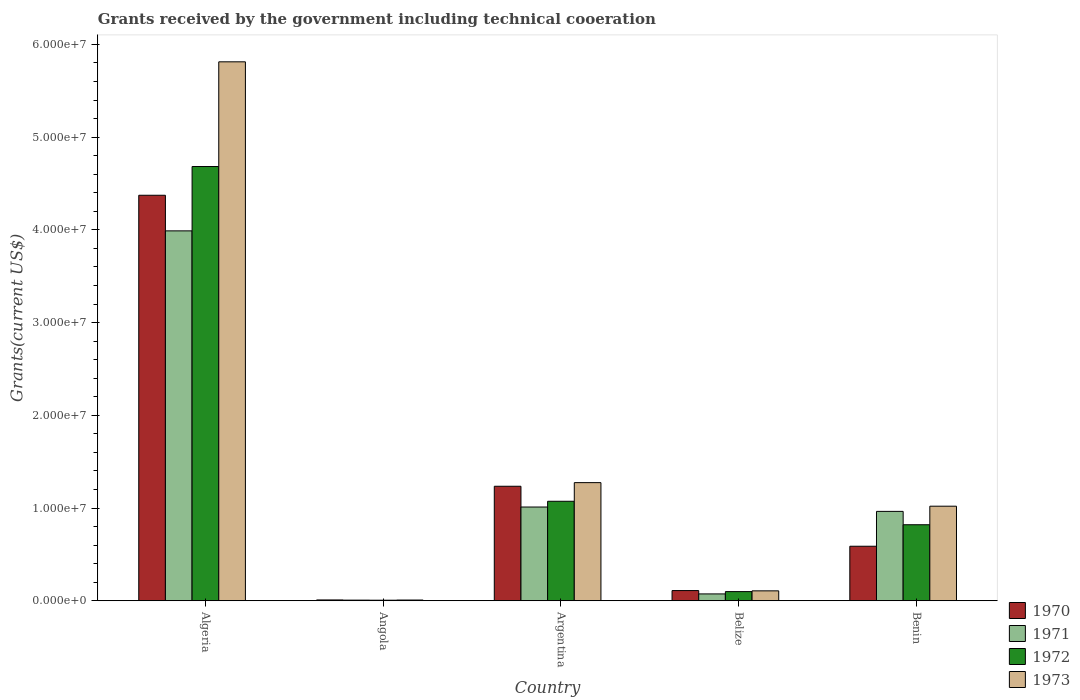Are the number of bars per tick equal to the number of legend labels?
Offer a terse response. Yes. Are the number of bars on each tick of the X-axis equal?
Ensure brevity in your answer.  Yes. How many bars are there on the 4th tick from the right?
Offer a terse response. 4. What is the label of the 4th group of bars from the left?
Ensure brevity in your answer.  Belize. In how many cases, is the number of bars for a given country not equal to the number of legend labels?
Ensure brevity in your answer.  0. What is the total grants received by the government in 1972 in Benin?
Keep it short and to the point. 8.20e+06. Across all countries, what is the maximum total grants received by the government in 1971?
Keep it short and to the point. 3.99e+07. Across all countries, what is the minimum total grants received by the government in 1971?
Your answer should be compact. 7.00e+04. In which country was the total grants received by the government in 1972 maximum?
Offer a terse response. Algeria. In which country was the total grants received by the government in 1973 minimum?
Keep it short and to the point. Angola. What is the total total grants received by the government in 1973 in the graph?
Your response must be concise. 8.22e+07. What is the difference between the total grants received by the government in 1972 in Algeria and that in Angola?
Give a very brief answer. 4.68e+07. What is the difference between the total grants received by the government in 1971 in Belize and the total grants received by the government in 1970 in Angola?
Your answer should be very brief. 6.50e+05. What is the average total grants received by the government in 1970 per country?
Keep it short and to the point. 1.26e+07. What is the difference between the total grants received by the government of/in 1971 and total grants received by the government of/in 1970 in Benin?
Offer a terse response. 3.76e+06. In how many countries, is the total grants received by the government in 1972 greater than 48000000 US$?
Keep it short and to the point. 0. What is the ratio of the total grants received by the government in 1973 in Argentina to that in Belize?
Offer a very short reply. 11.91. What is the difference between the highest and the second highest total grants received by the government in 1971?
Your response must be concise. 2.98e+07. What is the difference between the highest and the lowest total grants received by the government in 1973?
Make the answer very short. 5.80e+07. Is it the case that in every country, the sum of the total grants received by the government in 1973 and total grants received by the government in 1970 is greater than the sum of total grants received by the government in 1972 and total grants received by the government in 1971?
Your answer should be very brief. No. How many countries are there in the graph?
Ensure brevity in your answer.  5. What is the difference between two consecutive major ticks on the Y-axis?
Provide a succinct answer. 1.00e+07. Does the graph contain grids?
Provide a short and direct response. No. How are the legend labels stacked?
Offer a terse response. Vertical. What is the title of the graph?
Give a very brief answer. Grants received by the government including technical cooeration. Does "1994" appear as one of the legend labels in the graph?
Your answer should be very brief. No. What is the label or title of the X-axis?
Give a very brief answer. Country. What is the label or title of the Y-axis?
Your answer should be compact. Grants(current US$). What is the Grants(current US$) in 1970 in Algeria?
Provide a short and direct response. 4.37e+07. What is the Grants(current US$) of 1971 in Algeria?
Provide a succinct answer. 3.99e+07. What is the Grants(current US$) of 1972 in Algeria?
Give a very brief answer. 4.68e+07. What is the Grants(current US$) in 1973 in Algeria?
Offer a terse response. 5.81e+07. What is the Grants(current US$) in 1970 in Angola?
Your response must be concise. 9.00e+04. What is the Grants(current US$) of 1971 in Angola?
Offer a terse response. 7.00e+04. What is the Grants(current US$) in 1973 in Angola?
Your response must be concise. 8.00e+04. What is the Grants(current US$) in 1970 in Argentina?
Your answer should be compact. 1.24e+07. What is the Grants(current US$) of 1971 in Argentina?
Your response must be concise. 1.01e+07. What is the Grants(current US$) in 1972 in Argentina?
Make the answer very short. 1.07e+07. What is the Grants(current US$) of 1973 in Argentina?
Give a very brief answer. 1.27e+07. What is the Grants(current US$) of 1970 in Belize?
Your answer should be very brief. 1.10e+06. What is the Grants(current US$) in 1971 in Belize?
Keep it short and to the point. 7.40e+05. What is the Grants(current US$) in 1972 in Belize?
Offer a terse response. 9.90e+05. What is the Grants(current US$) in 1973 in Belize?
Your answer should be very brief. 1.07e+06. What is the Grants(current US$) in 1970 in Benin?
Your response must be concise. 5.88e+06. What is the Grants(current US$) of 1971 in Benin?
Your answer should be compact. 9.64e+06. What is the Grants(current US$) in 1972 in Benin?
Make the answer very short. 8.20e+06. What is the Grants(current US$) in 1973 in Benin?
Provide a short and direct response. 1.02e+07. Across all countries, what is the maximum Grants(current US$) of 1970?
Provide a short and direct response. 4.37e+07. Across all countries, what is the maximum Grants(current US$) in 1971?
Offer a very short reply. 3.99e+07. Across all countries, what is the maximum Grants(current US$) in 1972?
Offer a terse response. 4.68e+07. Across all countries, what is the maximum Grants(current US$) in 1973?
Offer a terse response. 5.81e+07. Across all countries, what is the minimum Grants(current US$) of 1971?
Provide a short and direct response. 7.00e+04. What is the total Grants(current US$) of 1970 in the graph?
Your answer should be compact. 6.32e+07. What is the total Grants(current US$) in 1971 in the graph?
Provide a succinct answer. 6.04e+07. What is the total Grants(current US$) in 1972 in the graph?
Ensure brevity in your answer.  6.68e+07. What is the total Grants(current US$) of 1973 in the graph?
Keep it short and to the point. 8.22e+07. What is the difference between the Grants(current US$) in 1970 in Algeria and that in Angola?
Keep it short and to the point. 4.36e+07. What is the difference between the Grants(current US$) of 1971 in Algeria and that in Angola?
Offer a very short reply. 3.98e+07. What is the difference between the Grants(current US$) of 1972 in Algeria and that in Angola?
Ensure brevity in your answer.  4.68e+07. What is the difference between the Grants(current US$) in 1973 in Algeria and that in Angola?
Offer a very short reply. 5.80e+07. What is the difference between the Grants(current US$) in 1970 in Algeria and that in Argentina?
Your answer should be compact. 3.14e+07. What is the difference between the Grants(current US$) of 1971 in Algeria and that in Argentina?
Provide a succinct answer. 2.98e+07. What is the difference between the Grants(current US$) of 1972 in Algeria and that in Argentina?
Keep it short and to the point. 3.61e+07. What is the difference between the Grants(current US$) of 1973 in Algeria and that in Argentina?
Offer a very short reply. 4.54e+07. What is the difference between the Grants(current US$) of 1970 in Algeria and that in Belize?
Keep it short and to the point. 4.26e+07. What is the difference between the Grants(current US$) in 1971 in Algeria and that in Belize?
Your answer should be compact. 3.92e+07. What is the difference between the Grants(current US$) in 1972 in Algeria and that in Belize?
Your response must be concise. 4.58e+07. What is the difference between the Grants(current US$) in 1973 in Algeria and that in Belize?
Provide a succinct answer. 5.70e+07. What is the difference between the Grants(current US$) in 1970 in Algeria and that in Benin?
Give a very brief answer. 3.78e+07. What is the difference between the Grants(current US$) of 1971 in Algeria and that in Benin?
Make the answer very short. 3.02e+07. What is the difference between the Grants(current US$) in 1972 in Algeria and that in Benin?
Your response must be concise. 3.86e+07. What is the difference between the Grants(current US$) in 1973 in Algeria and that in Benin?
Ensure brevity in your answer.  4.79e+07. What is the difference between the Grants(current US$) in 1970 in Angola and that in Argentina?
Give a very brief answer. -1.23e+07. What is the difference between the Grants(current US$) in 1971 in Angola and that in Argentina?
Keep it short and to the point. -1.00e+07. What is the difference between the Grants(current US$) of 1972 in Angola and that in Argentina?
Provide a short and direct response. -1.07e+07. What is the difference between the Grants(current US$) of 1973 in Angola and that in Argentina?
Give a very brief answer. -1.27e+07. What is the difference between the Grants(current US$) in 1970 in Angola and that in Belize?
Provide a succinct answer. -1.01e+06. What is the difference between the Grants(current US$) of 1971 in Angola and that in Belize?
Ensure brevity in your answer.  -6.70e+05. What is the difference between the Grants(current US$) in 1972 in Angola and that in Belize?
Your answer should be compact. -9.30e+05. What is the difference between the Grants(current US$) in 1973 in Angola and that in Belize?
Your answer should be very brief. -9.90e+05. What is the difference between the Grants(current US$) of 1970 in Angola and that in Benin?
Your response must be concise. -5.79e+06. What is the difference between the Grants(current US$) in 1971 in Angola and that in Benin?
Provide a short and direct response. -9.57e+06. What is the difference between the Grants(current US$) in 1972 in Angola and that in Benin?
Provide a succinct answer. -8.14e+06. What is the difference between the Grants(current US$) of 1973 in Angola and that in Benin?
Your answer should be very brief. -1.01e+07. What is the difference between the Grants(current US$) in 1970 in Argentina and that in Belize?
Provide a succinct answer. 1.12e+07. What is the difference between the Grants(current US$) in 1971 in Argentina and that in Belize?
Ensure brevity in your answer.  9.37e+06. What is the difference between the Grants(current US$) of 1972 in Argentina and that in Belize?
Make the answer very short. 9.74e+06. What is the difference between the Grants(current US$) in 1973 in Argentina and that in Belize?
Your answer should be compact. 1.17e+07. What is the difference between the Grants(current US$) of 1970 in Argentina and that in Benin?
Provide a short and direct response. 6.47e+06. What is the difference between the Grants(current US$) in 1971 in Argentina and that in Benin?
Your answer should be compact. 4.70e+05. What is the difference between the Grants(current US$) in 1972 in Argentina and that in Benin?
Ensure brevity in your answer.  2.53e+06. What is the difference between the Grants(current US$) of 1973 in Argentina and that in Benin?
Your answer should be compact. 2.54e+06. What is the difference between the Grants(current US$) of 1970 in Belize and that in Benin?
Provide a succinct answer. -4.78e+06. What is the difference between the Grants(current US$) of 1971 in Belize and that in Benin?
Keep it short and to the point. -8.90e+06. What is the difference between the Grants(current US$) of 1972 in Belize and that in Benin?
Provide a succinct answer. -7.21e+06. What is the difference between the Grants(current US$) of 1973 in Belize and that in Benin?
Your response must be concise. -9.13e+06. What is the difference between the Grants(current US$) of 1970 in Algeria and the Grants(current US$) of 1971 in Angola?
Give a very brief answer. 4.37e+07. What is the difference between the Grants(current US$) of 1970 in Algeria and the Grants(current US$) of 1972 in Angola?
Keep it short and to the point. 4.37e+07. What is the difference between the Grants(current US$) of 1970 in Algeria and the Grants(current US$) of 1973 in Angola?
Offer a terse response. 4.36e+07. What is the difference between the Grants(current US$) in 1971 in Algeria and the Grants(current US$) in 1972 in Angola?
Your answer should be compact. 3.98e+07. What is the difference between the Grants(current US$) of 1971 in Algeria and the Grants(current US$) of 1973 in Angola?
Offer a very short reply. 3.98e+07. What is the difference between the Grants(current US$) in 1972 in Algeria and the Grants(current US$) in 1973 in Angola?
Your answer should be very brief. 4.68e+07. What is the difference between the Grants(current US$) of 1970 in Algeria and the Grants(current US$) of 1971 in Argentina?
Provide a succinct answer. 3.36e+07. What is the difference between the Grants(current US$) in 1970 in Algeria and the Grants(current US$) in 1972 in Argentina?
Make the answer very short. 3.30e+07. What is the difference between the Grants(current US$) in 1970 in Algeria and the Grants(current US$) in 1973 in Argentina?
Your answer should be compact. 3.10e+07. What is the difference between the Grants(current US$) of 1971 in Algeria and the Grants(current US$) of 1972 in Argentina?
Give a very brief answer. 2.92e+07. What is the difference between the Grants(current US$) in 1971 in Algeria and the Grants(current US$) in 1973 in Argentina?
Your answer should be very brief. 2.72e+07. What is the difference between the Grants(current US$) in 1972 in Algeria and the Grants(current US$) in 1973 in Argentina?
Your response must be concise. 3.41e+07. What is the difference between the Grants(current US$) in 1970 in Algeria and the Grants(current US$) in 1971 in Belize?
Your answer should be compact. 4.30e+07. What is the difference between the Grants(current US$) in 1970 in Algeria and the Grants(current US$) in 1972 in Belize?
Offer a very short reply. 4.27e+07. What is the difference between the Grants(current US$) of 1970 in Algeria and the Grants(current US$) of 1973 in Belize?
Offer a very short reply. 4.27e+07. What is the difference between the Grants(current US$) in 1971 in Algeria and the Grants(current US$) in 1972 in Belize?
Ensure brevity in your answer.  3.89e+07. What is the difference between the Grants(current US$) in 1971 in Algeria and the Grants(current US$) in 1973 in Belize?
Make the answer very short. 3.88e+07. What is the difference between the Grants(current US$) in 1972 in Algeria and the Grants(current US$) in 1973 in Belize?
Your answer should be very brief. 4.58e+07. What is the difference between the Grants(current US$) of 1970 in Algeria and the Grants(current US$) of 1971 in Benin?
Make the answer very short. 3.41e+07. What is the difference between the Grants(current US$) in 1970 in Algeria and the Grants(current US$) in 1972 in Benin?
Your answer should be compact. 3.55e+07. What is the difference between the Grants(current US$) in 1970 in Algeria and the Grants(current US$) in 1973 in Benin?
Make the answer very short. 3.35e+07. What is the difference between the Grants(current US$) in 1971 in Algeria and the Grants(current US$) in 1972 in Benin?
Give a very brief answer. 3.17e+07. What is the difference between the Grants(current US$) of 1971 in Algeria and the Grants(current US$) of 1973 in Benin?
Provide a short and direct response. 2.97e+07. What is the difference between the Grants(current US$) of 1972 in Algeria and the Grants(current US$) of 1973 in Benin?
Your response must be concise. 3.66e+07. What is the difference between the Grants(current US$) of 1970 in Angola and the Grants(current US$) of 1971 in Argentina?
Keep it short and to the point. -1.00e+07. What is the difference between the Grants(current US$) of 1970 in Angola and the Grants(current US$) of 1972 in Argentina?
Your answer should be very brief. -1.06e+07. What is the difference between the Grants(current US$) in 1970 in Angola and the Grants(current US$) in 1973 in Argentina?
Make the answer very short. -1.26e+07. What is the difference between the Grants(current US$) of 1971 in Angola and the Grants(current US$) of 1972 in Argentina?
Your answer should be very brief. -1.07e+07. What is the difference between the Grants(current US$) in 1971 in Angola and the Grants(current US$) in 1973 in Argentina?
Provide a succinct answer. -1.27e+07. What is the difference between the Grants(current US$) of 1972 in Angola and the Grants(current US$) of 1973 in Argentina?
Provide a short and direct response. -1.27e+07. What is the difference between the Grants(current US$) in 1970 in Angola and the Grants(current US$) in 1971 in Belize?
Your answer should be compact. -6.50e+05. What is the difference between the Grants(current US$) of 1970 in Angola and the Grants(current US$) of 1972 in Belize?
Provide a succinct answer. -9.00e+05. What is the difference between the Grants(current US$) of 1970 in Angola and the Grants(current US$) of 1973 in Belize?
Offer a very short reply. -9.80e+05. What is the difference between the Grants(current US$) in 1971 in Angola and the Grants(current US$) in 1972 in Belize?
Your response must be concise. -9.20e+05. What is the difference between the Grants(current US$) in 1971 in Angola and the Grants(current US$) in 1973 in Belize?
Give a very brief answer. -1.00e+06. What is the difference between the Grants(current US$) of 1972 in Angola and the Grants(current US$) of 1973 in Belize?
Offer a very short reply. -1.01e+06. What is the difference between the Grants(current US$) of 1970 in Angola and the Grants(current US$) of 1971 in Benin?
Your answer should be compact. -9.55e+06. What is the difference between the Grants(current US$) of 1970 in Angola and the Grants(current US$) of 1972 in Benin?
Your response must be concise. -8.11e+06. What is the difference between the Grants(current US$) of 1970 in Angola and the Grants(current US$) of 1973 in Benin?
Provide a succinct answer. -1.01e+07. What is the difference between the Grants(current US$) of 1971 in Angola and the Grants(current US$) of 1972 in Benin?
Ensure brevity in your answer.  -8.13e+06. What is the difference between the Grants(current US$) of 1971 in Angola and the Grants(current US$) of 1973 in Benin?
Your response must be concise. -1.01e+07. What is the difference between the Grants(current US$) of 1972 in Angola and the Grants(current US$) of 1973 in Benin?
Give a very brief answer. -1.01e+07. What is the difference between the Grants(current US$) of 1970 in Argentina and the Grants(current US$) of 1971 in Belize?
Offer a terse response. 1.16e+07. What is the difference between the Grants(current US$) of 1970 in Argentina and the Grants(current US$) of 1972 in Belize?
Offer a very short reply. 1.14e+07. What is the difference between the Grants(current US$) of 1970 in Argentina and the Grants(current US$) of 1973 in Belize?
Your answer should be compact. 1.13e+07. What is the difference between the Grants(current US$) of 1971 in Argentina and the Grants(current US$) of 1972 in Belize?
Offer a very short reply. 9.12e+06. What is the difference between the Grants(current US$) of 1971 in Argentina and the Grants(current US$) of 1973 in Belize?
Keep it short and to the point. 9.04e+06. What is the difference between the Grants(current US$) in 1972 in Argentina and the Grants(current US$) in 1973 in Belize?
Provide a short and direct response. 9.66e+06. What is the difference between the Grants(current US$) in 1970 in Argentina and the Grants(current US$) in 1971 in Benin?
Offer a very short reply. 2.71e+06. What is the difference between the Grants(current US$) of 1970 in Argentina and the Grants(current US$) of 1972 in Benin?
Offer a very short reply. 4.15e+06. What is the difference between the Grants(current US$) of 1970 in Argentina and the Grants(current US$) of 1973 in Benin?
Make the answer very short. 2.15e+06. What is the difference between the Grants(current US$) in 1971 in Argentina and the Grants(current US$) in 1972 in Benin?
Offer a terse response. 1.91e+06. What is the difference between the Grants(current US$) in 1971 in Argentina and the Grants(current US$) in 1973 in Benin?
Your response must be concise. -9.00e+04. What is the difference between the Grants(current US$) in 1972 in Argentina and the Grants(current US$) in 1973 in Benin?
Offer a very short reply. 5.30e+05. What is the difference between the Grants(current US$) in 1970 in Belize and the Grants(current US$) in 1971 in Benin?
Ensure brevity in your answer.  -8.54e+06. What is the difference between the Grants(current US$) of 1970 in Belize and the Grants(current US$) of 1972 in Benin?
Keep it short and to the point. -7.10e+06. What is the difference between the Grants(current US$) of 1970 in Belize and the Grants(current US$) of 1973 in Benin?
Provide a succinct answer. -9.10e+06. What is the difference between the Grants(current US$) of 1971 in Belize and the Grants(current US$) of 1972 in Benin?
Your answer should be very brief. -7.46e+06. What is the difference between the Grants(current US$) in 1971 in Belize and the Grants(current US$) in 1973 in Benin?
Offer a terse response. -9.46e+06. What is the difference between the Grants(current US$) in 1972 in Belize and the Grants(current US$) in 1973 in Benin?
Make the answer very short. -9.21e+06. What is the average Grants(current US$) of 1970 per country?
Offer a terse response. 1.26e+07. What is the average Grants(current US$) of 1971 per country?
Your answer should be compact. 1.21e+07. What is the average Grants(current US$) of 1972 per country?
Your response must be concise. 1.34e+07. What is the average Grants(current US$) of 1973 per country?
Make the answer very short. 1.64e+07. What is the difference between the Grants(current US$) in 1970 and Grants(current US$) in 1971 in Algeria?
Offer a very short reply. 3.84e+06. What is the difference between the Grants(current US$) in 1970 and Grants(current US$) in 1972 in Algeria?
Provide a short and direct response. -3.10e+06. What is the difference between the Grants(current US$) of 1970 and Grants(current US$) of 1973 in Algeria?
Give a very brief answer. -1.44e+07. What is the difference between the Grants(current US$) of 1971 and Grants(current US$) of 1972 in Algeria?
Your answer should be compact. -6.94e+06. What is the difference between the Grants(current US$) of 1971 and Grants(current US$) of 1973 in Algeria?
Keep it short and to the point. -1.82e+07. What is the difference between the Grants(current US$) of 1972 and Grants(current US$) of 1973 in Algeria?
Ensure brevity in your answer.  -1.13e+07. What is the difference between the Grants(current US$) of 1970 and Grants(current US$) of 1971 in Angola?
Provide a succinct answer. 2.00e+04. What is the difference between the Grants(current US$) of 1970 and Grants(current US$) of 1972 in Angola?
Your response must be concise. 3.00e+04. What is the difference between the Grants(current US$) in 1970 and Grants(current US$) in 1973 in Angola?
Provide a succinct answer. 10000. What is the difference between the Grants(current US$) in 1972 and Grants(current US$) in 1973 in Angola?
Your response must be concise. -2.00e+04. What is the difference between the Grants(current US$) in 1970 and Grants(current US$) in 1971 in Argentina?
Ensure brevity in your answer.  2.24e+06. What is the difference between the Grants(current US$) of 1970 and Grants(current US$) of 1972 in Argentina?
Your answer should be compact. 1.62e+06. What is the difference between the Grants(current US$) of 1970 and Grants(current US$) of 1973 in Argentina?
Offer a very short reply. -3.90e+05. What is the difference between the Grants(current US$) in 1971 and Grants(current US$) in 1972 in Argentina?
Make the answer very short. -6.20e+05. What is the difference between the Grants(current US$) of 1971 and Grants(current US$) of 1973 in Argentina?
Give a very brief answer. -2.63e+06. What is the difference between the Grants(current US$) of 1972 and Grants(current US$) of 1973 in Argentina?
Provide a short and direct response. -2.01e+06. What is the difference between the Grants(current US$) of 1971 and Grants(current US$) of 1972 in Belize?
Keep it short and to the point. -2.50e+05. What is the difference between the Grants(current US$) of 1971 and Grants(current US$) of 1973 in Belize?
Your response must be concise. -3.30e+05. What is the difference between the Grants(current US$) in 1970 and Grants(current US$) in 1971 in Benin?
Your answer should be compact. -3.76e+06. What is the difference between the Grants(current US$) of 1970 and Grants(current US$) of 1972 in Benin?
Offer a terse response. -2.32e+06. What is the difference between the Grants(current US$) of 1970 and Grants(current US$) of 1973 in Benin?
Offer a very short reply. -4.32e+06. What is the difference between the Grants(current US$) of 1971 and Grants(current US$) of 1972 in Benin?
Ensure brevity in your answer.  1.44e+06. What is the difference between the Grants(current US$) of 1971 and Grants(current US$) of 1973 in Benin?
Offer a terse response. -5.60e+05. What is the difference between the Grants(current US$) in 1972 and Grants(current US$) in 1973 in Benin?
Give a very brief answer. -2.00e+06. What is the ratio of the Grants(current US$) in 1970 in Algeria to that in Angola?
Provide a succinct answer. 485.89. What is the ratio of the Grants(current US$) of 1971 in Algeria to that in Angola?
Provide a short and direct response. 569.86. What is the ratio of the Grants(current US$) in 1972 in Algeria to that in Angola?
Your answer should be very brief. 780.5. What is the ratio of the Grants(current US$) of 1973 in Algeria to that in Angola?
Offer a terse response. 726.5. What is the ratio of the Grants(current US$) of 1970 in Algeria to that in Argentina?
Keep it short and to the point. 3.54. What is the ratio of the Grants(current US$) in 1971 in Algeria to that in Argentina?
Your answer should be compact. 3.95. What is the ratio of the Grants(current US$) in 1972 in Algeria to that in Argentina?
Offer a very short reply. 4.36. What is the ratio of the Grants(current US$) of 1973 in Algeria to that in Argentina?
Ensure brevity in your answer.  4.56. What is the ratio of the Grants(current US$) in 1970 in Algeria to that in Belize?
Offer a very short reply. 39.75. What is the ratio of the Grants(current US$) in 1971 in Algeria to that in Belize?
Ensure brevity in your answer.  53.91. What is the ratio of the Grants(current US$) in 1972 in Algeria to that in Belize?
Offer a terse response. 47.3. What is the ratio of the Grants(current US$) in 1973 in Algeria to that in Belize?
Provide a short and direct response. 54.32. What is the ratio of the Grants(current US$) of 1970 in Algeria to that in Benin?
Provide a succinct answer. 7.44. What is the ratio of the Grants(current US$) of 1971 in Algeria to that in Benin?
Give a very brief answer. 4.14. What is the ratio of the Grants(current US$) of 1972 in Algeria to that in Benin?
Ensure brevity in your answer.  5.71. What is the ratio of the Grants(current US$) in 1973 in Algeria to that in Benin?
Keep it short and to the point. 5.7. What is the ratio of the Grants(current US$) in 1970 in Angola to that in Argentina?
Ensure brevity in your answer.  0.01. What is the ratio of the Grants(current US$) in 1971 in Angola to that in Argentina?
Give a very brief answer. 0.01. What is the ratio of the Grants(current US$) of 1972 in Angola to that in Argentina?
Ensure brevity in your answer.  0.01. What is the ratio of the Grants(current US$) in 1973 in Angola to that in Argentina?
Offer a terse response. 0.01. What is the ratio of the Grants(current US$) in 1970 in Angola to that in Belize?
Offer a terse response. 0.08. What is the ratio of the Grants(current US$) in 1971 in Angola to that in Belize?
Give a very brief answer. 0.09. What is the ratio of the Grants(current US$) in 1972 in Angola to that in Belize?
Make the answer very short. 0.06. What is the ratio of the Grants(current US$) in 1973 in Angola to that in Belize?
Offer a very short reply. 0.07. What is the ratio of the Grants(current US$) of 1970 in Angola to that in Benin?
Provide a short and direct response. 0.02. What is the ratio of the Grants(current US$) of 1971 in Angola to that in Benin?
Make the answer very short. 0.01. What is the ratio of the Grants(current US$) of 1972 in Angola to that in Benin?
Give a very brief answer. 0.01. What is the ratio of the Grants(current US$) of 1973 in Angola to that in Benin?
Ensure brevity in your answer.  0.01. What is the ratio of the Grants(current US$) in 1970 in Argentina to that in Belize?
Make the answer very short. 11.23. What is the ratio of the Grants(current US$) of 1971 in Argentina to that in Belize?
Keep it short and to the point. 13.66. What is the ratio of the Grants(current US$) of 1972 in Argentina to that in Belize?
Offer a terse response. 10.84. What is the ratio of the Grants(current US$) of 1973 in Argentina to that in Belize?
Your answer should be compact. 11.91. What is the ratio of the Grants(current US$) in 1970 in Argentina to that in Benin?
Your answer should be very brief. 2.1. What is the ratio of the Grants(current US$) of 1971 in Argentina to that in Benin?
Provide a succinct answer. 1.05. What is the ratio of the Grants(current US$) of 1972 in Argentina to that in Benin?
Keep it short and to the point. 1.31. What is the ratio of the Grants(current US$) of 1973 in Argentina to that in Benin?
Your answer should be very brief. 1.25. What is the ratio of the Grants(current US$) of 1970 in Belize to that in Benin?
Ensure brevity in your answer.  0.19. What is the ratio of the Grants(current US$) in 1971 in Belize to that in Benin?
Your answer should be very brief. 0.08. What is the ratio of the Grants(current US$) of 1972 in Belize to that in Benin?
Provide a short and direct response. 0.12. What is the ratio of the Grants(current US$) in 1973 in Belize to that in Benin?
Keep it short and to the point. 0.1. What is the difference between the highest and the second highest Grants(current US$) in 1970?
Keep it short and to the point. 3.14e+07. What is the difference between the highest and the second highest Grants(current US$) of 1971?
Provide a succinct answer. 2.98e+07. What is the difference between the highest and the second highest Grants(current US$) of 1972?
Make the answer very short. 3.61e+07. What is the difference between the highest and the second highest Grants(current US$) in 1973?
Offer a very short reply. 4.54e+07. What is the difference between the highest and the lowest Grants(current US$) in 1970?
Your answer should be compact. 4.36e+07. What is the difference between the highest and the lowest Grants(current US$) of 1971?
Make the answer very short. 3.98e+07. What is the difference between the highest and the lowest Grants(current US$) of 1972?
Provide a short and direct response. 4.68e+07. What is the difference between the highest and the lowest Grants(current US$) in 1973?
Make the answer very short. 5.80e+07. 